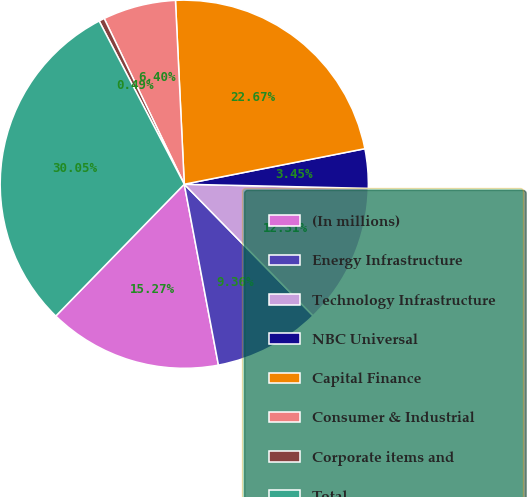Convert chart to OTSL. <chart><loc_0><loc_0><loc_500><loc_500><pie_chart><fcel>(In millions)<fcel>Energy Infrastructure<fcel>Technology Infrastructure<fcel>NBC Universal<fcel>Capital Finance<fcel>Consumer & Industrial<fcel>Corporate items and<fcel>Total<nl><fcel>15.27%<fcel>9.36%<fcel>12.31%<fcel>3.45%<fcel>22.67%<fcel>6.4%<fcel>0.49%<fcel>30.05%<nl></chart> 